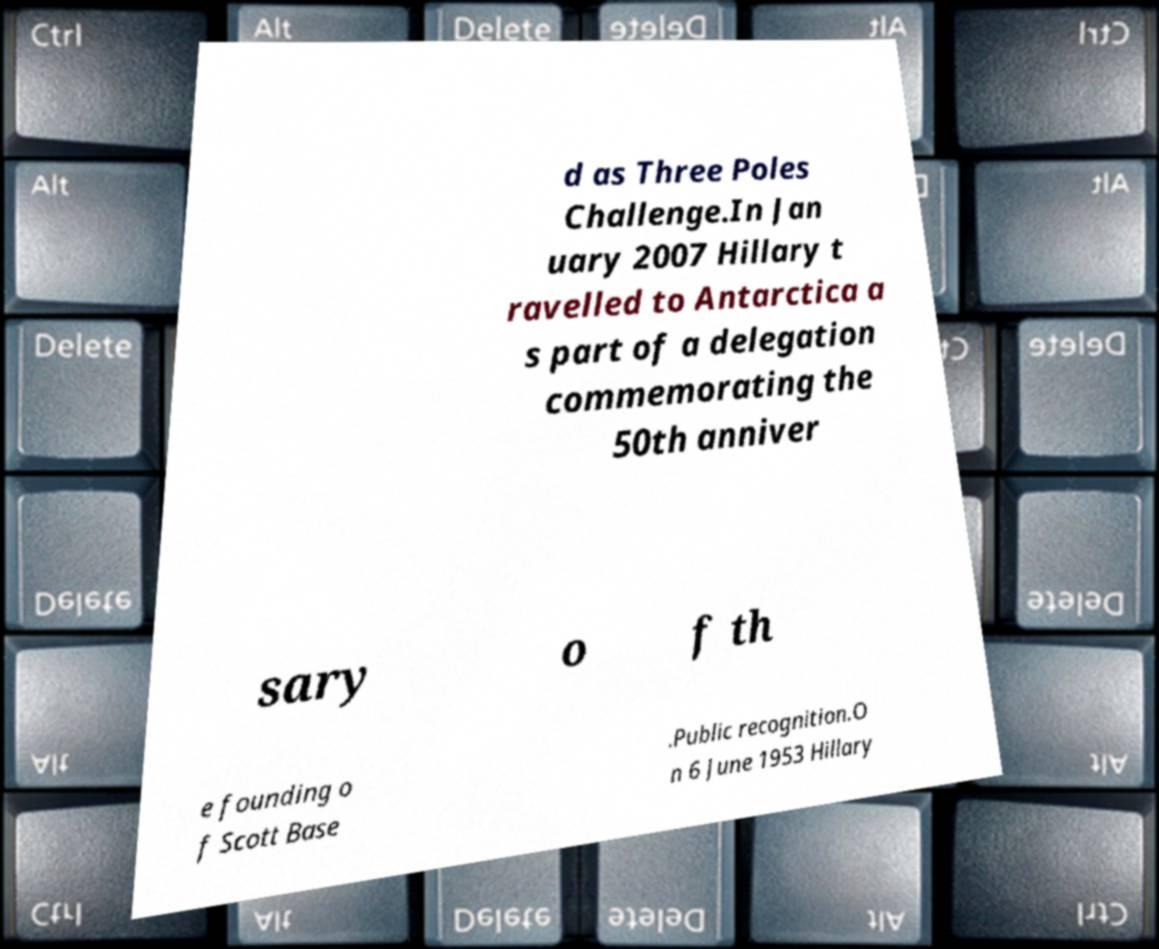I need the written content from this picture converted into text. Can you do that? d as Three Poles Challenge.In Jan uary 2007 Hillary t ravelled to Antarctica a s part of a delegation commemorating the 50th anniver sary o f th e founding o f Scott Base .Public recognition.O n 6 June 1953 Hillary 